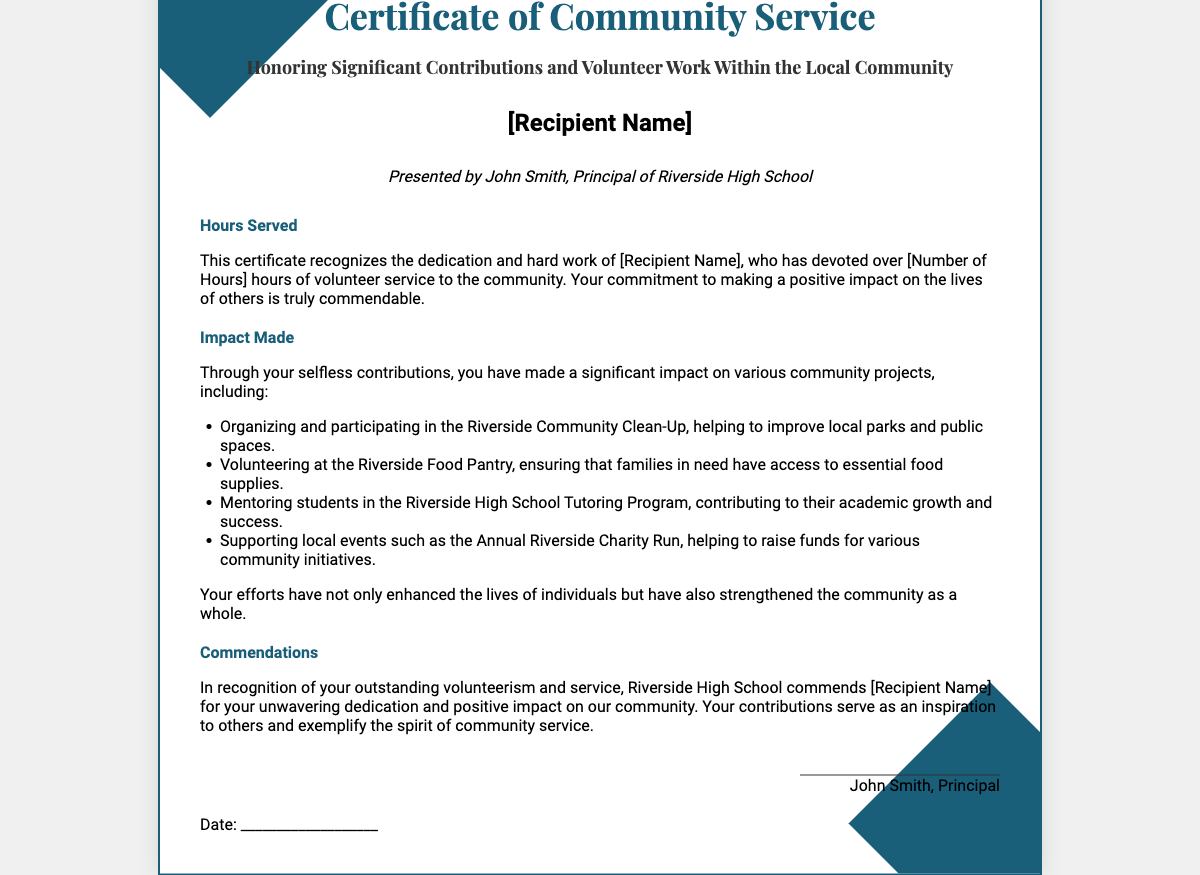What is the title of the certificate? The title is presented prominently at the top of the document, indicating the purpose of the award.
Answer: Certificate of Community Service Who presented the certificate? The document specifies the individual who is presenting the certificate, indicating their position and association.
Answer: John Smith, Principal of Riverside High School What is the focus of the community service recognized in this certificate? The certificate outlines the significant contributions and volunteer work within the local community.
Answer: Volunteer work How many hours of service are recognized in the certificate? The document includes a specific placeholder for the number of hours served by the recipient.
Answer: [Number of Hours] Which community project involved improving local parks? One of the community service activities listed focuses on enhancing public spaces through organized efforts.
Answer: Riverside Community Clean-Up What type of organization does the recipient volunteer at for food supplies? The certificate mentions involvement with an organization that provides essential food to those in need.
Answer: Riverside Food Pantry What is the purpose of the commendations section? This section serves to formally recognize the efforts and impact made by the recipient through their volunteerism.
Answer: Recognizing outstanding volunteerism What is the expected date to be filled in on the certificate? The document includes a specific area for writing down the formal date of presentation.
Answer: ___________________ What is one of the roles mentioned related to mentoring? The document lists a specific program where the recipient contributed to the academic growth of students.
Answer: Riverside High School Tutoring Program 